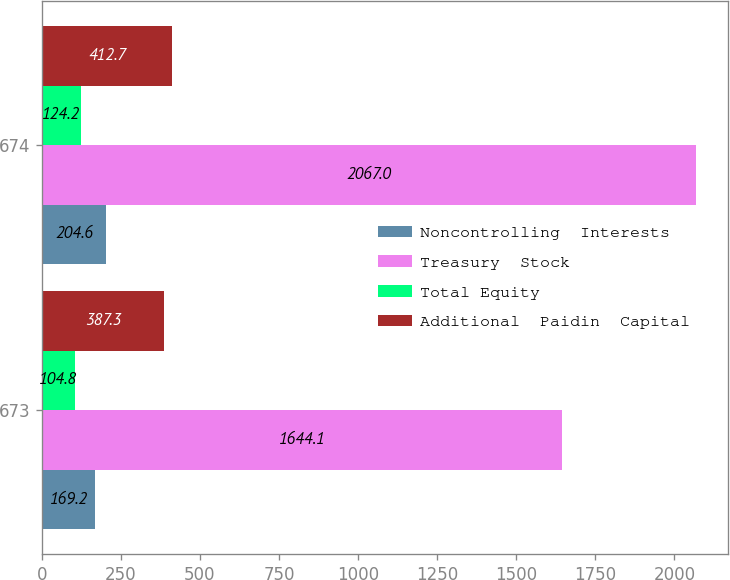Convert chart to OTSL. <chart><loc_0><loc_0><loc_500><loc_500><stacked_bar_chart><ecel><fcel>673<fcel>674<nl><fcel>Noncontrolling  Interests<fcel>169.2<fcel>204.6<nl><fcel>Treasury  Stock<fcel>1644.1<fcel>2067<nl><fcel>Total Equity<fcel>104.8<fcel>124.2<nl><fcel>Additional  Paidin  Capital<fcel>387.3<fcel>412.7<nl></chart> 